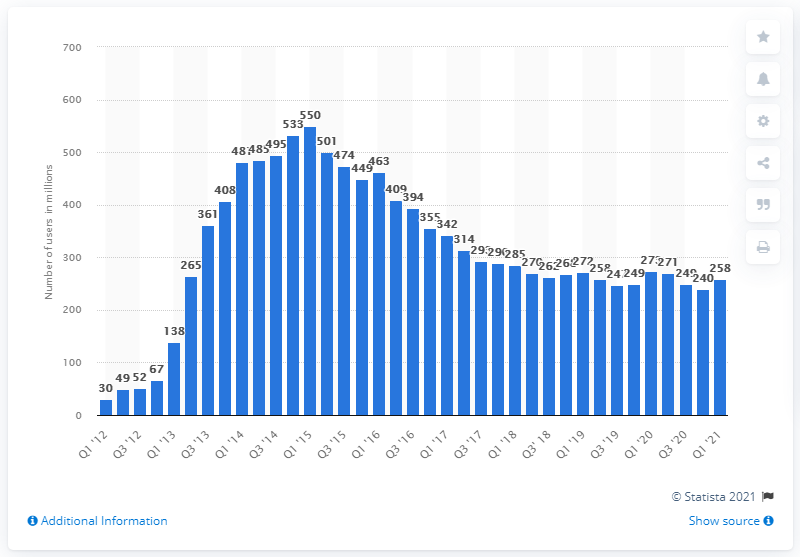Identify some key points in this picture. In the first quarter of 2021, King's apps were accessed by approximately 258 people per month. 